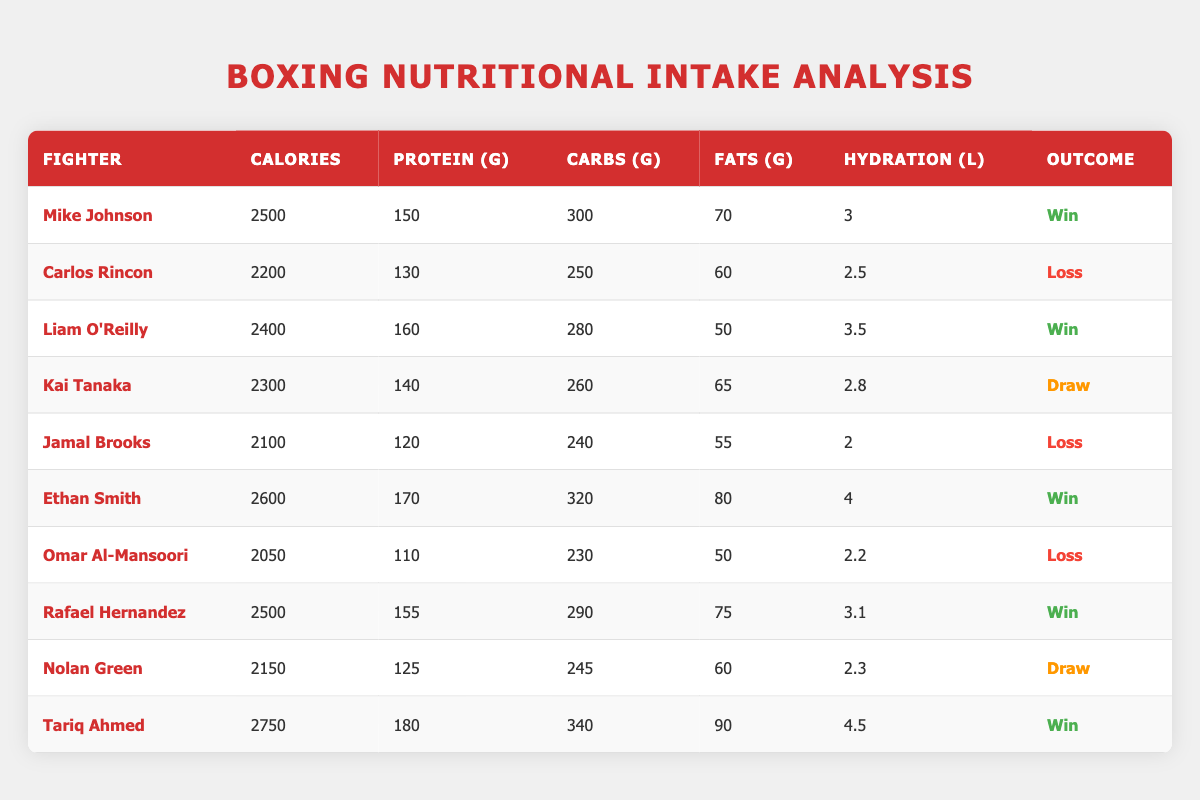What is the highest calorie intake reported among the fighters? The highest calorie intake in the table is listed under Tariq Ahmed with 2750 calories.
Answer: 2750 Which fighter has the second-highest protein intake? The fighter with the second-highest protein intake is Ethan Smith with 170 grams, while Tariq Ahmed has the highest with 180 grams.
Answer: Ethan Smith Is the performance outcome of Carlos Rincon a win? Based on the table, Carlos Rincon has a performance outcome of "Loss," confirming the answer is no.
Answer: No What is the average hydration level for fighters who won their matches? First, sum the hydration levels of winning fighters: 3 + 3.5 + 4 + 3.1 + 4.5 = 18.1 liters. There are 5 winners, so the average is 18.1 / 5 = 3.62 liters.
Answer: 3.62 How many fighters had a performance outcome of "Draw"? The table lists two fighters with a performance outcome of "Draw" (Kai Tanaka and Nolan Green).
Answer: 2 What is the difference in grams of protein intake between the fighter with the highest and the lowest protein intake? The highest protein intake is by Tariq Ahmed with 180 grams, and the lowest is by Omar Al-Mansoori with 110 grams. The difference is 180 - 110 = 70 grams.
Answer: 70 Did any fighter with a caloric intake above 2500 calories lose their match? The table indicates that Tariq Ahmed has the highest caloric intake of 2750 and has a performance outcome of "Win." Therefore, no fighter above 2500 calories lost.
Answer: No What is the total fat intake for fighters who drew their matches? The total fat intake for fighters who drew their matches is 65 grams from Kai Tanaka and 60 grams from Nolan Green. The total is 65 + 60 = 125 grams.
Answer: 125 How many grams of carbohydrates did Mike Johnson consume in comparison to Carlos Rincon? Mike Johnson consumed 300 grams of carbohydrates while Carlos Rincon had 250 grams, so Mike Johnson consumed more by 300 - 250 = 50 grams.
Answer: 50 